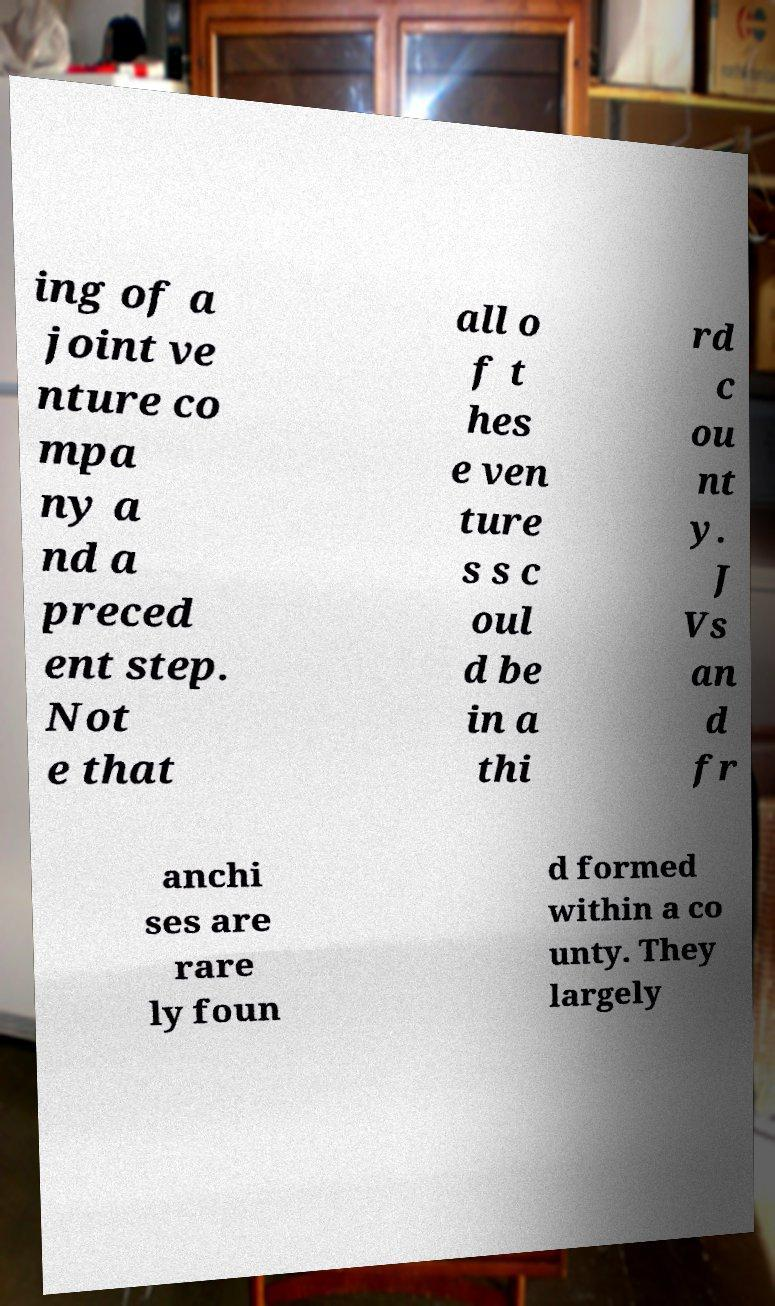Could you extract and type out the text from this image? ing of a joint ve nture co mpa ny a nd a preced ent step. Not e that all o f t hes e ven ture s s c oul d be in a thi rd c ou nt y. J Vs an d fr anchi ses are rare ly foun d formed within a co unty. They largely 